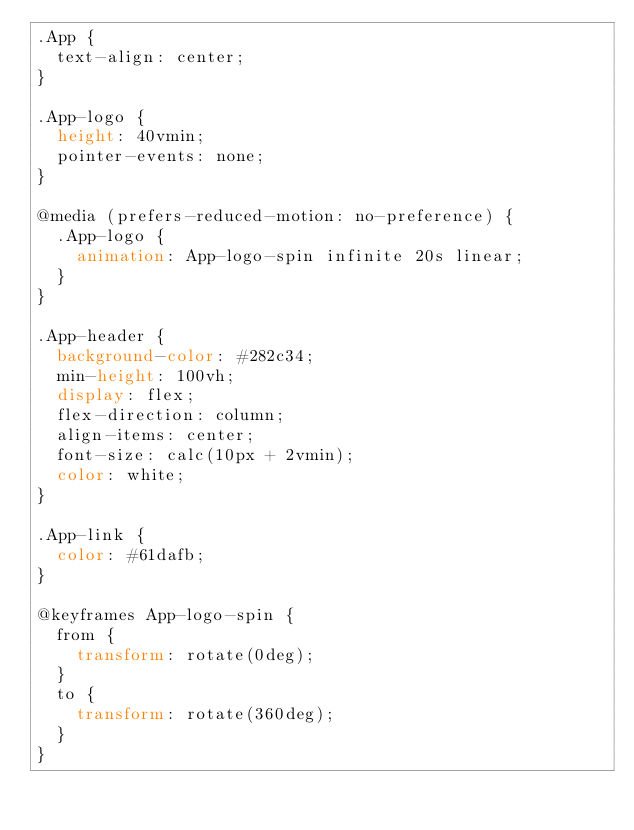<code> <loc_0><loc_0><loc_500><loc_500><_CSS_>.App {
  text-align: center;
}

.App-logo {
  height: 40vmin;
  pointer-events: none;
}

@media (prefers-reduced-motion: no-preference) {
  .App-logo {
    animation: App-logo-spin infinite 20s linear;
  }
}

.App-header {
  background-color: #282c34;
  min-height: 100vh;
  display: flex;
  flex-direction: column;
  align-items: center;
  font-size: calc(10px + 2vmin);
  color: white;
}

.App-link {
  color: #61dafb;
}

@keyframes App-logo-spin {
  from {
    transform: rotate(0deg);
  }
  to {
    transform: rotate(360deg);
  }
}
</code> 